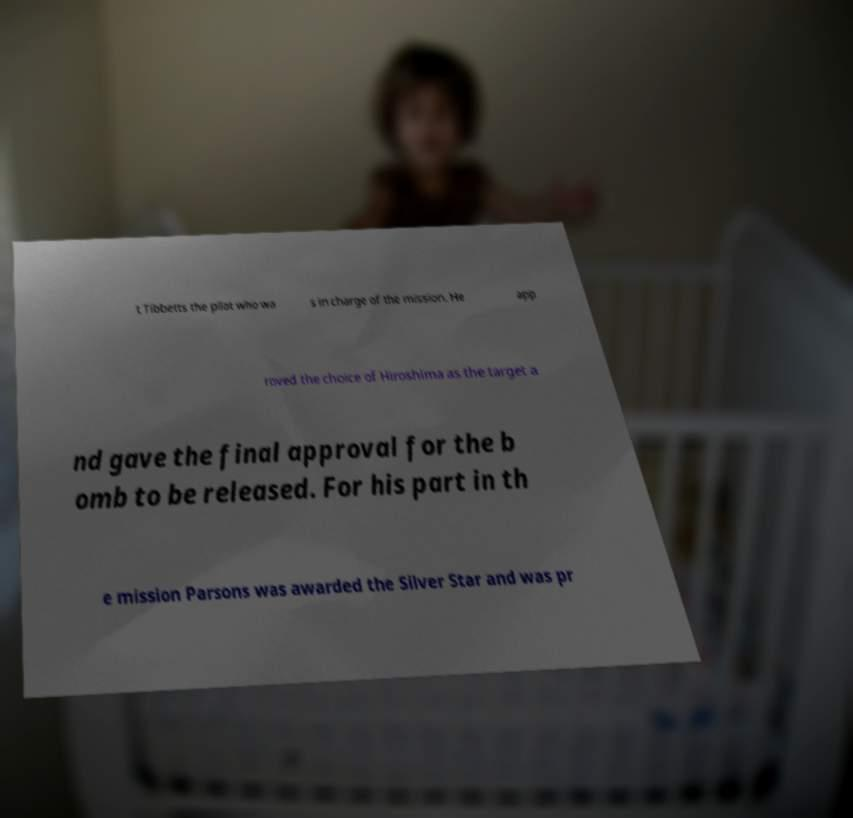Please read and relay the text visible in this image. What does it say? t Tibbetts the pilot who wa s in charge of the mission. He app roved the choice of Hiroshima as the target a nd gave the final approval for the b omb to be released. For his part in th e mission Parsons was awarded the Silver Star and was pr 